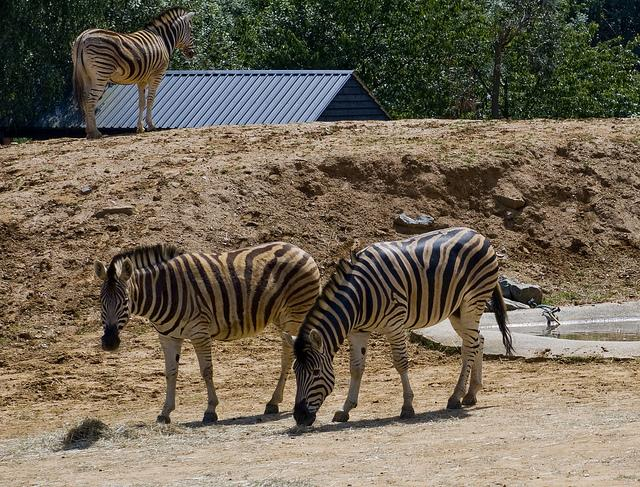How many zebras are walking around on top of the dirt in the courtyard? three 